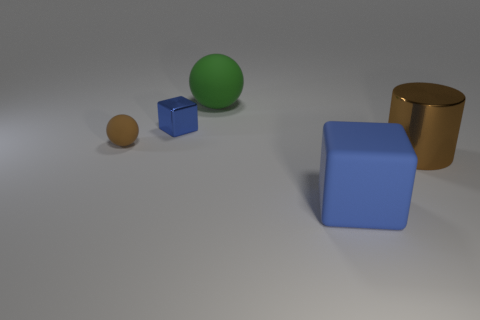Subtract all red balls. Subtract all red blocks. How many balls are left? 2 Add 2 brown spheres. How many objects exist? 7 Subtract all spheres. How many objects are left? 3 Add 2 small metallic things. How many small metallic things are left? 3 Add 5 tiny blue blocks. How many tiny blue blocks exist? 6 Subtract 0 red cylinders. How many objects are left? 5 Subtract all blue matte things. Subtract all large green objects. How many objects are left? 3 